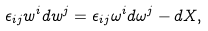<formula> <loc_0><loc_0><loc_500><loc_500>\epsilon _ { i j } w ^ { i } d w ^ { j } = \epsilon _ { i j } \omega ^ { i } d \omega ^ { j } - d X ,</formula> 